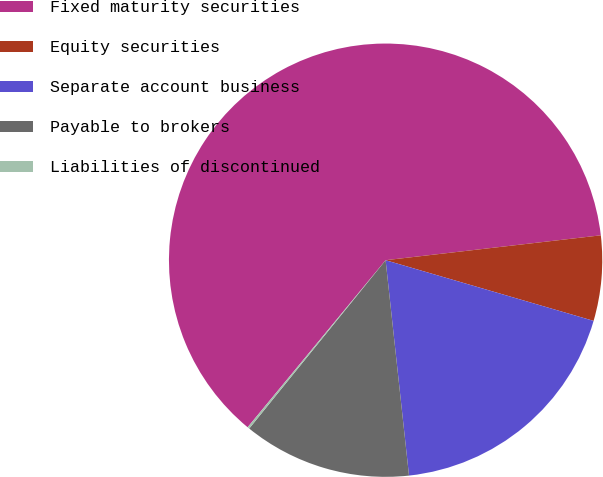<chart> <loc_0><loc_0><loc_500><loc_500><pie_chart><fcel>Fixed maturity securities<fcel>Equity securities<fcel>Separate account business<fcel>Payable to brokers<fcel>Liabilities of discontinued<nl><fcel>62.18%<fcel>6.35%<fcel>18.76%<fcel>12.56%<fcel>0.15%<nl></chart> 